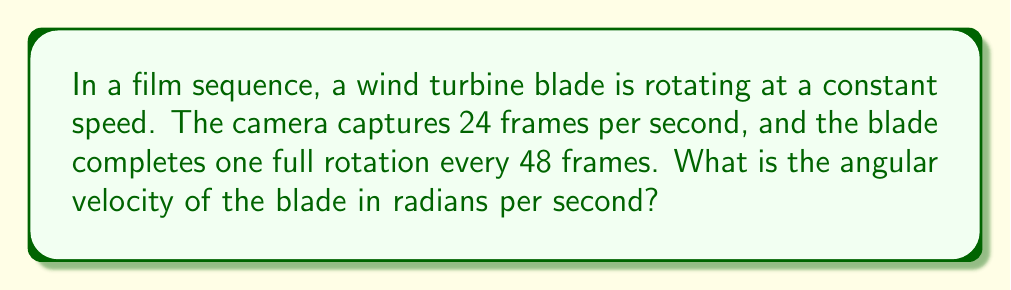Show me your answer to this math problem. Let's approach this step-by-step:

1) First, we need to determine how many rotations the blade makes per second:
   - 1 rotation takes 48 frames
   - There are 24 frames per second
   - Rotations per second = $\frac{24 \text{ frames/s}}{48 \text{ frames/rotation}} = 0.5 \text{ rotations/s}$

2) Now, we need to convert rotations per second to radians per second:
   - 1 rotation = $2\pi$ radians
   - Angular velocity (ω) = rotations per second × $2\pi$

3) Let's calculate:
   $$\omega = 0.5 \text{ rotations/s} \times 2\pi \text{ radians/rotation}$$
   $$\omega = \pi \text{ radians/s}$$

4) Therefore, the angular velocity of the wind turbine blade is $\pi$ radians per second.
Answer: $\pi \text{ rad/s}$ 